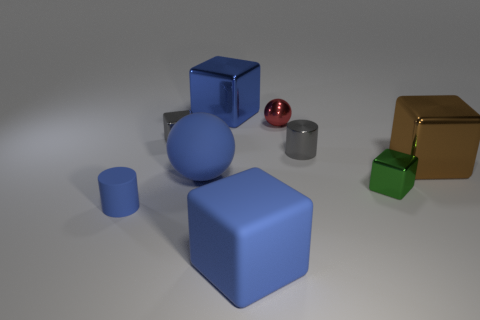There is a shiny cube that is the same color as the big rubber sphere; what is its size?
Your answer should be compact. Large. Do the ball that is right of the blue ball and the tiny block on the right side of the tiny gray metallic cylinder have the same color?
Offer a very short reply. No. The brown metal object has what size?
Keep it short and to the point. Large. What number of large things are gray objects or blue blocks?
Your answer should be compact. 2. What is the color of the ball that is the same size as the gray cylinder?
Offer a very short reply. Red. How many other objects are the same shape as the small blue thing?
Offer a terse response. 1. Is there a green ball made of the same material as the green thing?
Make the answer very short. No. Are the small red object behind the rubber cube and the large blue cube in front of the green shiny cube made of the same material?
Provide a succinct answer. No. What number of small green blocks are there?
Your answer should be compact. 1. There is a big metallic thing that is to the right of the red metallic ball; what is its shape?
Make the answer very short. Cube. 